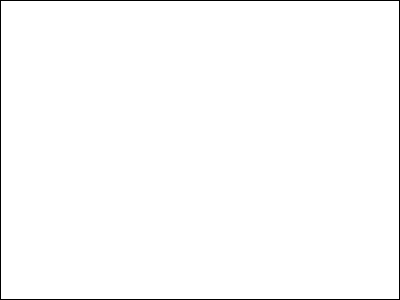Analyze the image and identify three characteristic elements of Baroque art present in this fresco by Giovanni Battista Tiepolo. How do these elements contribute to the overall Baroque aesthetic? To identify the characteristic elements of Baroque art in this fresco by Tiepolo, we need to consider the following steps:

1. Composition:
   - The fresco shows a dramatic, asymmetrical composition typical of Baroque art.
   - There's a sense of movement and energy, with figures arranged in a swirling, diagonal pattern.

2. Use of light and shadow:
   - Tiepolo employs strong contrasts between light and dark areas (chiaroscuro).
   - The central figure of Apollo is highlighted, drawing the viewer's attention.

3. Theatricality and grandeur:
   - The scene is presented in a highly dramatic, almost theatrical manner.
   - The figures are portrayed in exaggerated, dynamic poses.

4. Rich color palette:
   - Tiepolo uses vibrant, warm colors typical of Baroque painting.
   - The sky is painted in a luminous blue, contrasting with the warmer tones of the figures.

5. Illusionistic effects:
   - The fresco creates an illusion of depth and three-dimensionality.
   - Figures seem to emerge from and recede into space, blurring the boundary between real and painted architecture.

6. Allegorical and mythological subject matter:
   - The fresco depicts Apollo, the god of arts, surrounded by allegorical representations of the continents.
   - This complex iconography is characteristic of Baroque ceiling paintings.

These elements contribute to the overall Baroque aesthetic by creating a sense of drama, movement, and emotional intensity. The composition draws the viewer's eye upward and invites them to engage with the complex narrative. The use of light, color, and illusionistic effects enhances the sense of spectacle and grandeur, typical of Baroque art's aim to inspire awe and emotional response in the viewer.
Answer: Dramatic composition, chiaroscuro, theatrical presentation 